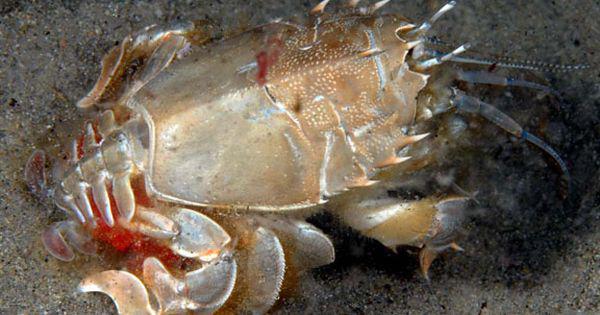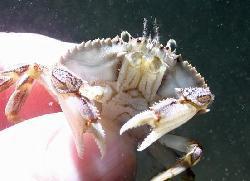The first image is the image on the left, the second image is the image on the right. Given the left and right images, does the statement "in at least one image there is a single carb facing forward in water with coral in the background." hold true? Answer yes or no. No. The first image is the image on the left, the second image is the image on the right. Assess this claim about the two images: "The right image shows the top view of a crab with a grainy grayish shell, and the left image shows at least one crab with a pinker shell and yellow-tinted claws.". Correct or not? Answer yes or no. No. 